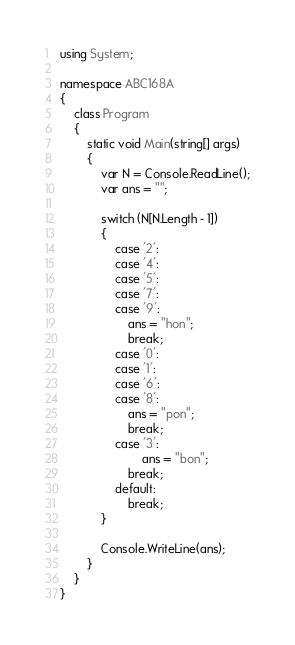<code> <loc_0><loc_0><loc_500><loc_500><_C#_>using System;

namespace ABC168A
{
    class Program
    {
        static void Main(string[] args)
        {
            var N = Console.ReadLine();
            var ans = "";

            switch (N[N.Length - 1])
            {
                case '2':
                case '4':
                case '5':
                case '7':
                case '9':
                    ans = "hon";
                    break;
                case '0':
                case '1':
                case '6':
                case '8':
                    ans = "pon";
                    break;
                case '3':
                        ans = "bon";
                    break;
                default:
                    break;
            }

            Console.WriteLine(ans);
        }
    }
}
</code> 